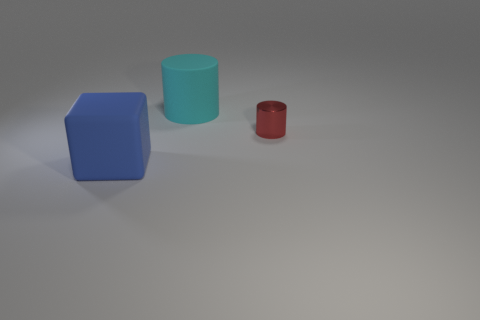Add 2 gray shiny blocks. How many objects exist? 5 Subtract all cylinders. How many objects are left? 1 Add 2 small shiny cylinders. How many small shiny cylinders exist? 3 Subtract 0 red cubes. How many objects are left? 3 Subtract all large green cylinders. Subtract all blue matte objects. How many objects are left? 2 Add 3 metallic cylinders. How many metallic cylinders are left? 4 